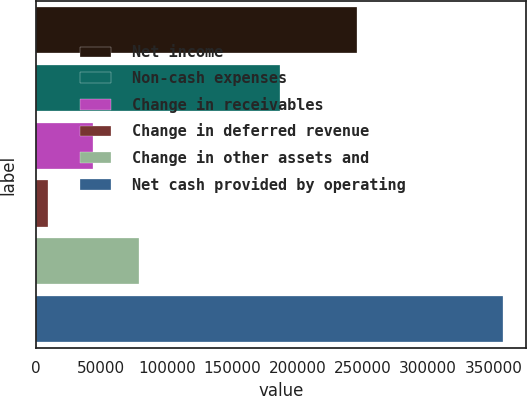Convert chart to OTSL. <chart><loc_0><loc_0><loc_500><loc_500><bar_chart><fcel>Net income<fcel>Non-cash expenses<fcel>Change in receivables<fcel>Change in deferred revenue<fcel>Change in other assets and<fcel>Net cash provided by operating<nl><fcel>245793<fcel>186626<fcel>43652.2<fcel>8800<fcel>78504.4<fcel>357322<nl></chart> 